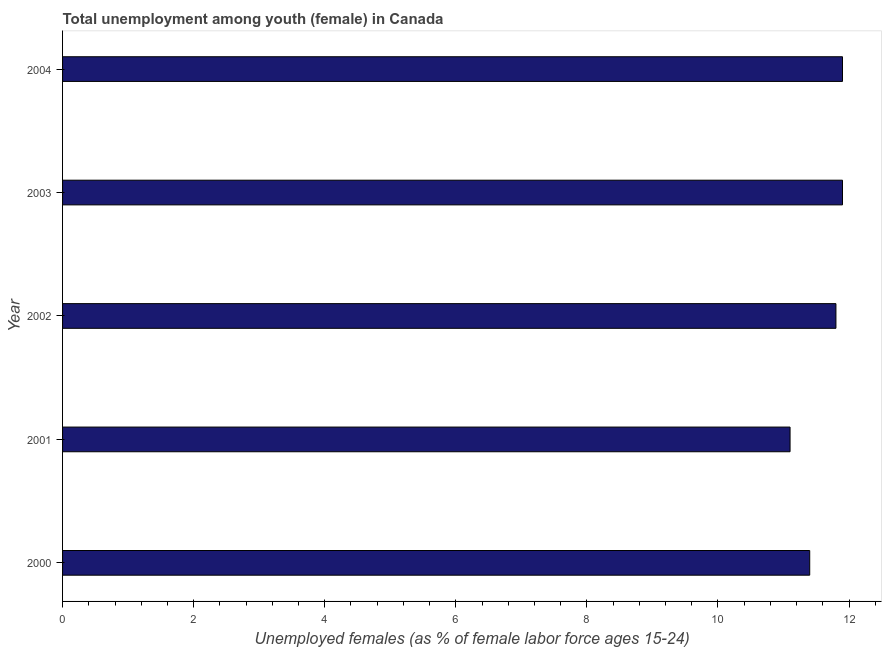Does the graph contain grids?
Offer a terse response. No. What is the title of the graph?
Your answer should be compact. Total unemployment among youth (female) in Canada. What is the label or title of the X-axis?
Provide a short and direct response. Unemployed females (as % of female labor force ages 15-24). What is the unemployed female youth population in 2003?
Your answer should be compact. 11.9. Across all years, what is the maximum unemployed female youth population?
Your answer should be very brief. 11.9. Across all years, what is the minimum unemployed female youth population?
Offer a terse response. 11.1. In which year was the unemployed female youth population minimum?
Your answer should be very brief. 2001. What is the sum of the unemployed female youth population?
Give a very brief answer. 58.1. What is the difference between the unemployed female youth population in 2002 and 2003?
Offer a very short reply. -0.1. What is the average unemployed female youth population per year?
Make the answer very short. 11.62. What is the median unemployed female youth population?
Your response must be concise. 11.8. Do a majority of the years between 2000 and 2004 (inclusive) have unemployed female youth population greater than 12 %?
Offer a terse response. No. What is the ratio of the unemployed female youth population in 2002 to that in 2003?
Provide a short and direct response. 0.99. Is the unemployed female youth population in 2001 less than that in 2003?
Ensure brevity in your answer.  Yes. What is the difference between the highest and the second highest unemployed female youth population?
Provide a short and direct response. 0. What is the difference between the highest and the lowest unemployed female youth population?
Offer a terse response. 0.8. How many years are there in the graph?
Keep it short and to the point. 5. What is the Unemployed females (as % of female labor force ages 15-24) of 2000?
Your response must be concise. 11.4. What is the Unemployed females (as % of female labor force ages 15-24) in 2001?
Ensure brevity in your answer.  11.1. What is the Unemployed females (as % of female labor force ages 15-24) of 2002?
Your answer should be compact. 11.8. What is the Unemployed females (as % of female labor force ages 15-24) in 2003?
Give a very brief answer. 11.9. What is the Unemployed females (as % of female labor force ages 15-24) of 2004?
Your answer should be very brief. 11.9. What is the difference between the Unemployed females (as % of female labor force ages 15-24) in 2000 and 2001?
Your answer should be compact. 0.3. What is the difference between the Unemployed females (as % of female labor force ages 15-24) in 2000 and 2002?
Provide a succinct answer. -0.4. What is the difference between the Unemployed females (as % of female labor force ages 15-24) in 2002 and 2003?
Make the answer very short. -0.1. What is the difference between the Unemployed females (as % of female labor force ages 15-24) in 2003 and 2004?
Offer a very short reply. 0. What is the ratio of the Unemployed females (as % of female labor force ages 15-24) in 2000 to that in 2001?
Your response must be concise. 1.03. What is the ratio of the Unemployed females (as % of female labor force ages 15-24) in 2000 to that in 2002?
Ensure brevity in your answer.  0.97. What is the ratio of the Unemployed females (as % of female labor force ages 15-24) in 2000 to that in 2003?
Your answer should be very brief. 0.96. What is the ratio of the Unemployed females (as % of female labor force ages 15-24) in 2000 to that in 2004?
Offer a terse response. 0.96. What is the ratio of the Unemployed females (as % of female labor force ages 15-24) in 2001 to that in 2002?
Offer a very short reply. 0.94. What is the ratio of the Unemployed females (as % of female labor force ages 15-24) in 2001 to that in 2003?
Your answer should be very brief. 0.93. What is the ratio of the Unemployed females (as % of female labor force ages 15-24) in 2001 to that in 2004?
Offer a terse response. 0.93. What is the ratio of the Unemployed females (as % of female labor force ages 15-24) in 2002 to that in 2003?
Offer a very short reply. 0.99. What is the ratio of the Unemployed females (as % of female labor force ages 15-24) in 2002 to that in 2004?
Provide a short and direct response. 0.99. 